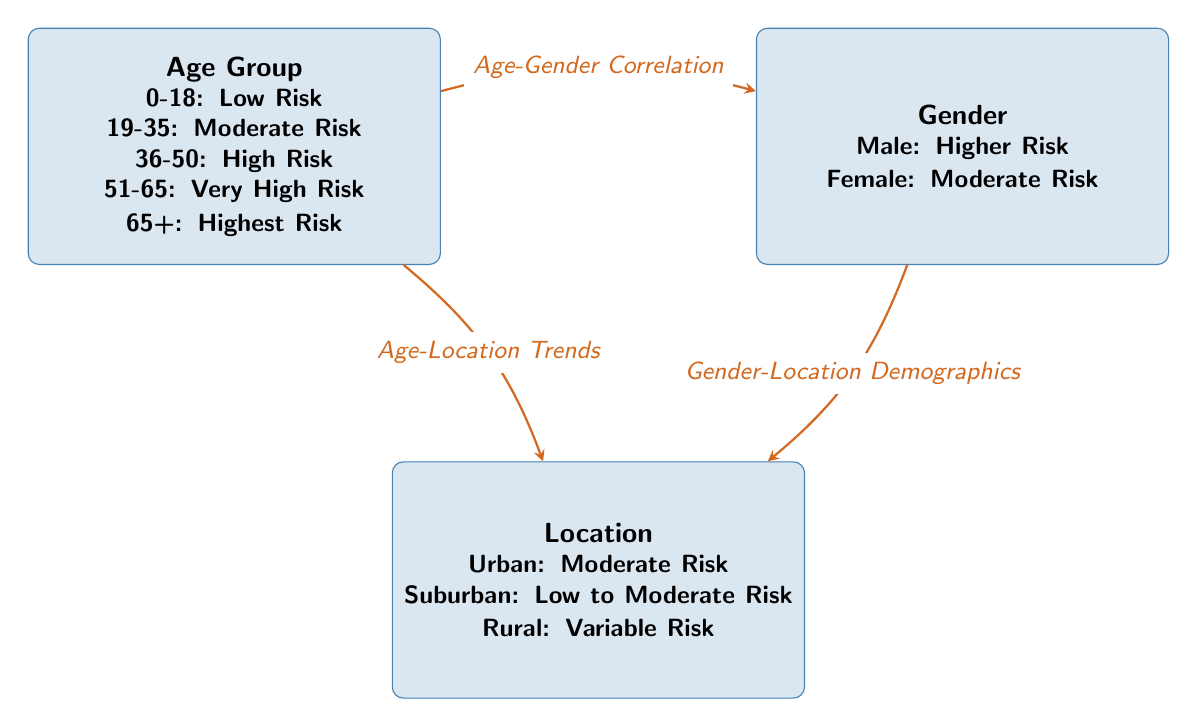What is the risk level for the age group 0-18? The diagram specifies that the risk level for the age group 0-18 is categorized as "Low Risk." This can be directly found in the node labeled 'Age Group.'
Answer: Low Risk Which gender is associated with higher risk? The node labeled 'Gender' indicates that "Male" is associated with higher risk, making it clear that this demographic has a greater risk level compared to females.
Answer: Male How many age groups are represented in the diagram? The 'Age Group' node contains five distinct classifications ranging from 0-18 to 65+, indicating there are five age groups represented.
Answer: Five What is the risk level for rural location? According to the 'Location' node in the diagram, the risk level for a rural location is identified as "Variable Risk." This means the risk can fluctuate based on various factors.
Answer: Variable Risk Which age group is associated with the highest risk? The 'Age Group' node shows that the age group 65+ is categorized as "Highest Risk." This indicates that individuals in this age bracket face the greatest risk exposure compared to other groups.
Answer: Highest Risk What relationship exists between age and gender in the diagram? The diagram shows an edge labeled "Age-Gender Correlation," indicating that there is a direct connection or relationship focused on how different age groups correlate with gender in terms of risk exposure.
Answer: Age-Gender Correlation What is the risk category for suburban locations? The diagram's 'Location' node specifies that suburban areas are classified under "Low to Moderate Risk," indicating a more favorable risk context compared to urban areas.
Answer: Low to Moderate Risk Which demographic has a moderate risk exposure according to both age and location? Age group 19-35 and urban location are both categorized as "Moderate Risk," showing that individuals in this age range living in urban areas share this level of risk exposure.
Answer: Moderate Risk What type of risks do females represent according to the diagram? The diagram highlights that females represent "Moderate Risk," as indicated in the 'Gender' node, distinguishing their risk classification from males.
Answer: Moderate Risk 